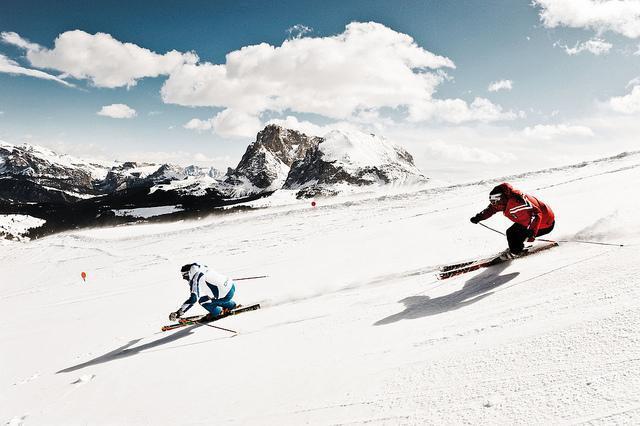How many people are visible?
Give a very brief answer. 2. 